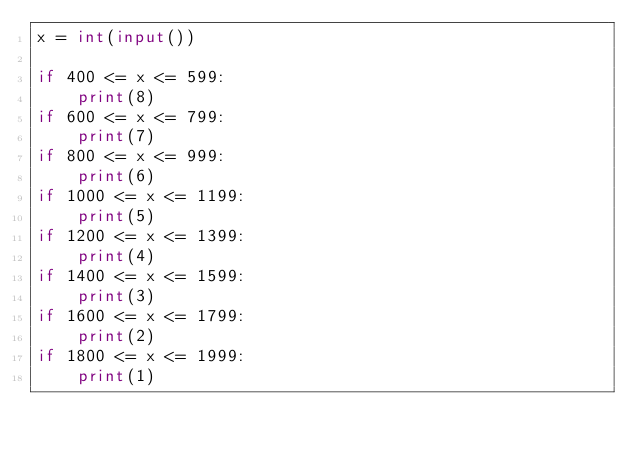<code> <loc_0><loc_0><loc_500><loc_500><_Python_>x = int(input())

if 400 <= x <= 599:
    print(8)
if 600 <= x <= 799:
    print(7)
if 800 <= x <= 999:
    print(6)
if 1000 <= x <= 1199:
    print(5)
if 1200 <= x <= 1399:
    print(4)
if 1400 <= x <= 1599:
    print(3)
if 1600 <= x <= 1799:
    print(2)
if 1800 <= x <= 1999:
    print(1)</code> 